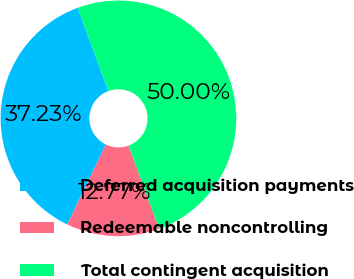Convert chart to OTSL. <chart><loc_0><loc_0><loc_500><loc_500><pie_chart><fcel>Deferred acquisition payments<fcel>Redeemable noncontrolling<fcel>Total contingent acquisition<nl><fcel>37.23%<fcel>12.77%<fcel>50.0%<nl></chart> 